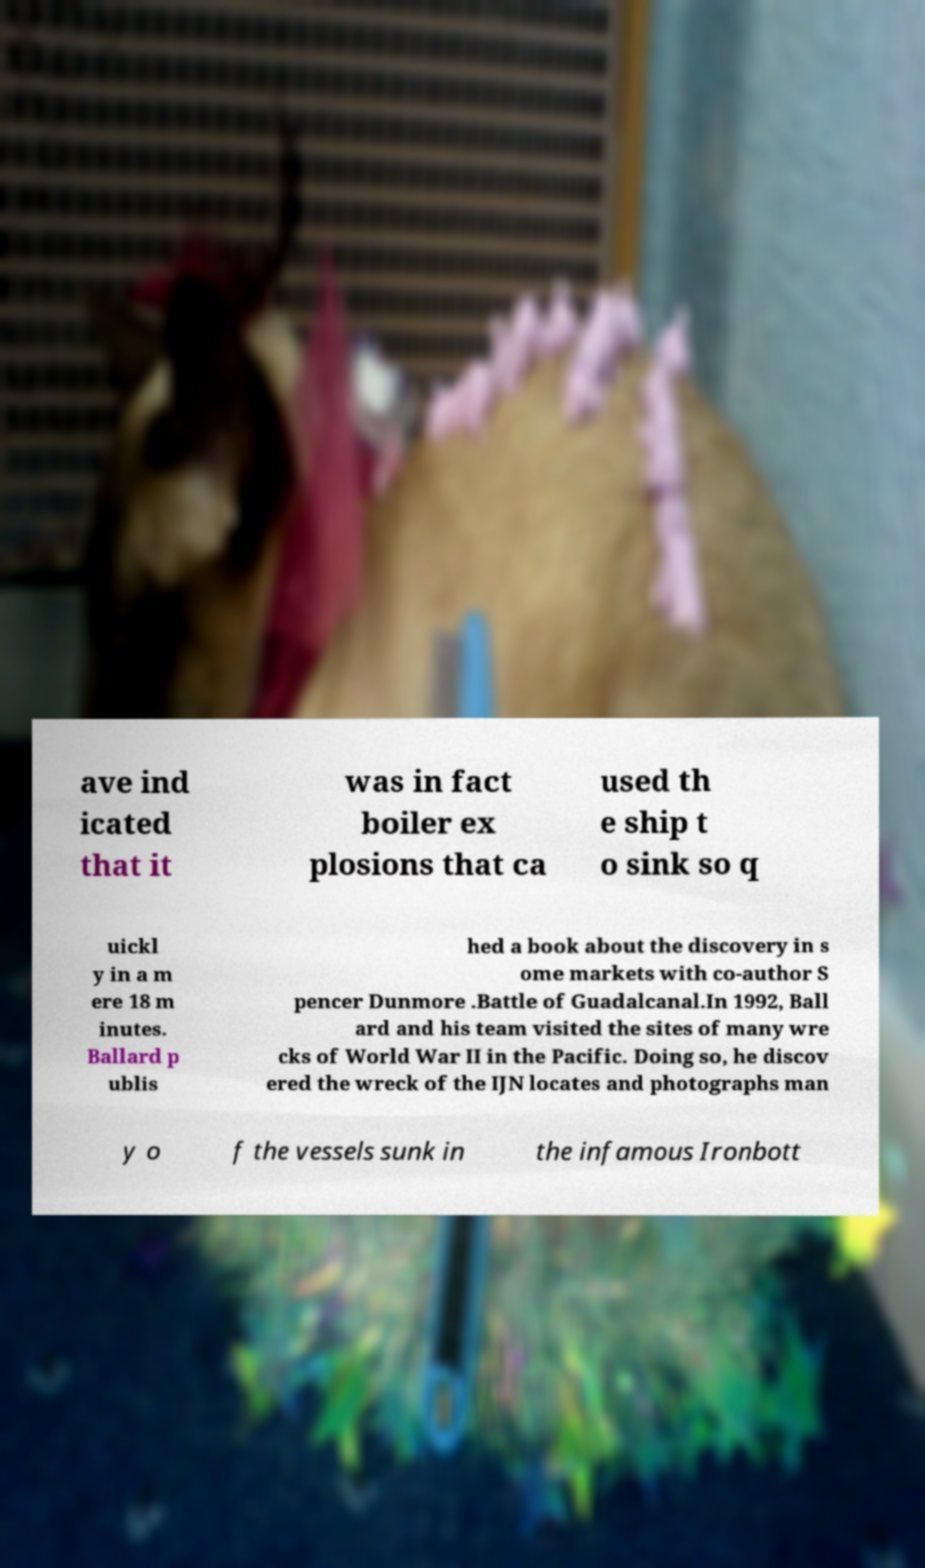Please read and relay the text visible in this image. What does it say? ave ind icated that it was in fact boiler ex plosions that ca used th e ship t o sink so q uickl y in a m ere 18 m inutes. Ballard p ublis hed a book about the discovery in s ome markets with co-author S pencer Dunmore .Battle of Guadalcanal.In 1992, Ball ard and his team visited the sites of many wre cks of World War II in the Pacific. Doing so, he discov ered the wreck of the IJN locates and photographs man y o f the vessels sunk in the infamous Ironbott 